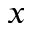Convert formula to latex. <formula><loc_0><loc_0><loc_500><loc_500>x</formula> 